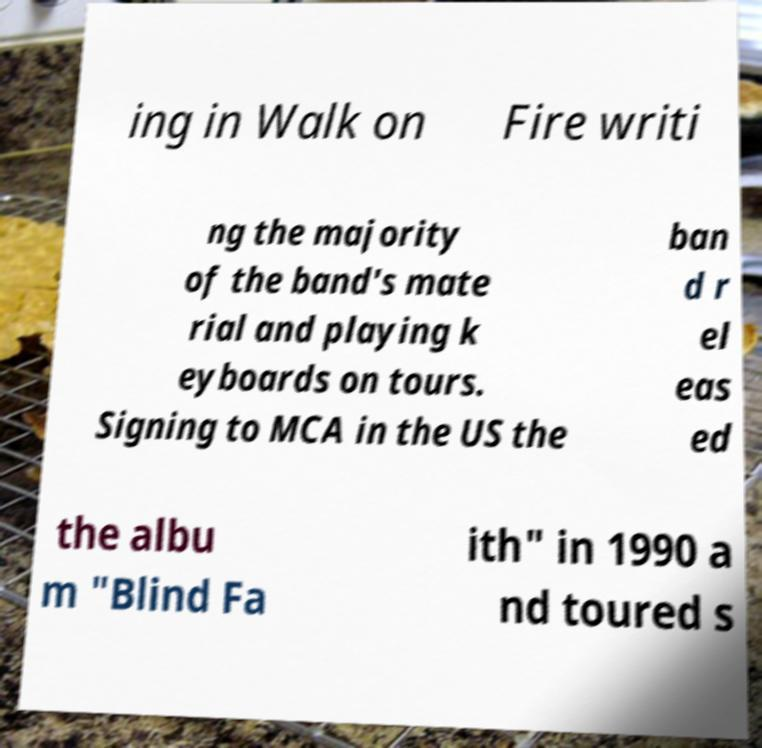Could you assist in decoding the text presented in this image and type it out clearly? ing in Walk on Fire writi ng the majority of the band's mate rial and playing k eyboards on tours. Signing to MCA in the US the ban d r el eas ed the albu m "Blind Fa ith" in 1990 a nd toured s 